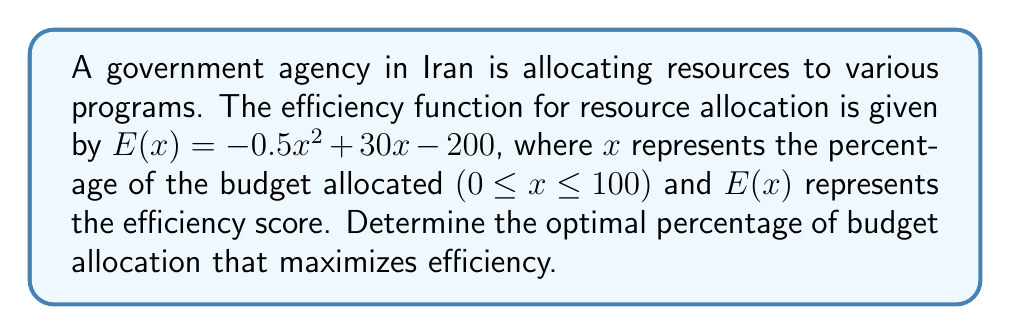What is the answer to this math problem? To find the maximum efficiency point, we need to find the vertex of the parabola described by the efficiency function. This can be done using calculus:

1. Find the derivative of the efficiency function:
   $$E'(x) = -x + 30$$

2. Set the derivative equal to zero to find the critical point:
   $$-x + 30 = 0$$
   $$x = 30$$

3. Verify that this critical point is a maximum by checking the second derivative:
   $$E''(x) = -1$$
   Since $E''(x)$ is negative, the critical point is a maximum.

4. Check if the maximum point falls within the domain (0 ≤ x ≤ 100):
   30 is within the range [0, 100], so this is a valid solution.

5. Calculate the maximum efficiency:
   $$E(30) = -0.5(30)^2 + 30(30) - 200 = 250$$

Therefore, the optimal percentage of budget allocation that maximizes efficiency is 30%.
Answer: 30% 